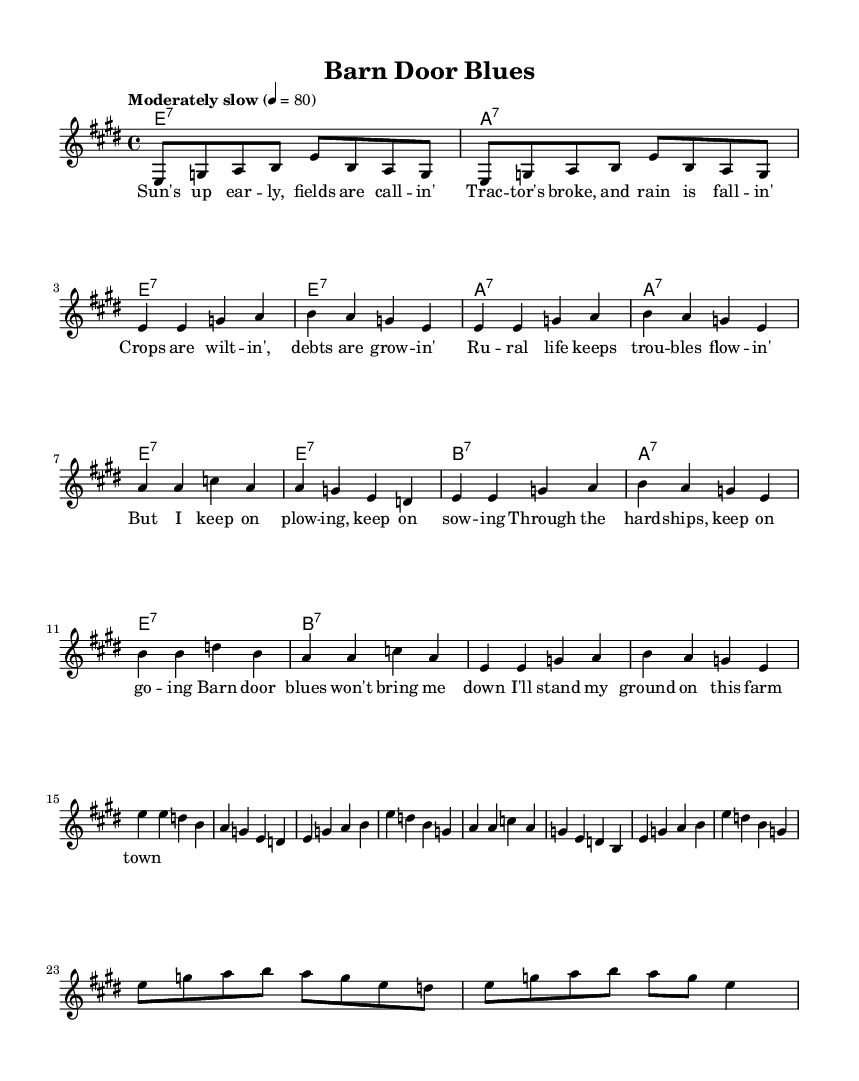What is the key signature of this music? The key signature is E major, which has four sharps: F-sharp, C-sharp, G-sharp, and D-sharp.
Answer: E major What is the time signature of the music? The time signature is indicated at the beginning of the piece, showing that there are four beats in a measure and a quarter note gets one beat.
Answer: 4/4 What is the tempo marking of the piece? The tempo marking specifies a speed of 80 beats per minute, indicating that the music should be played moderately slow.
Answer: Moderately slow How many measures are in the verse melody? Counting the measures in the verse melody section, there are 8 measures in total before it transitions to the chorus.
Answer: 8 What chord is played at the beginning of the chorus? The first chord of the chorus is identified in the chord names section; it corresponds to the chord marking above the music.
Answer: E seventh What type of instrument features a solo in this piece? The harmonica is the instrument that features a solo, which is highlighted in the section designated for the harmonica solo.
Answer: Harmonica What is the primary theme of the lyrics in the song? Analyzing the verses and chorus reveals that the theme revolves around the struggles of rural life and farming difficulties.
Answer: Rural struggles 